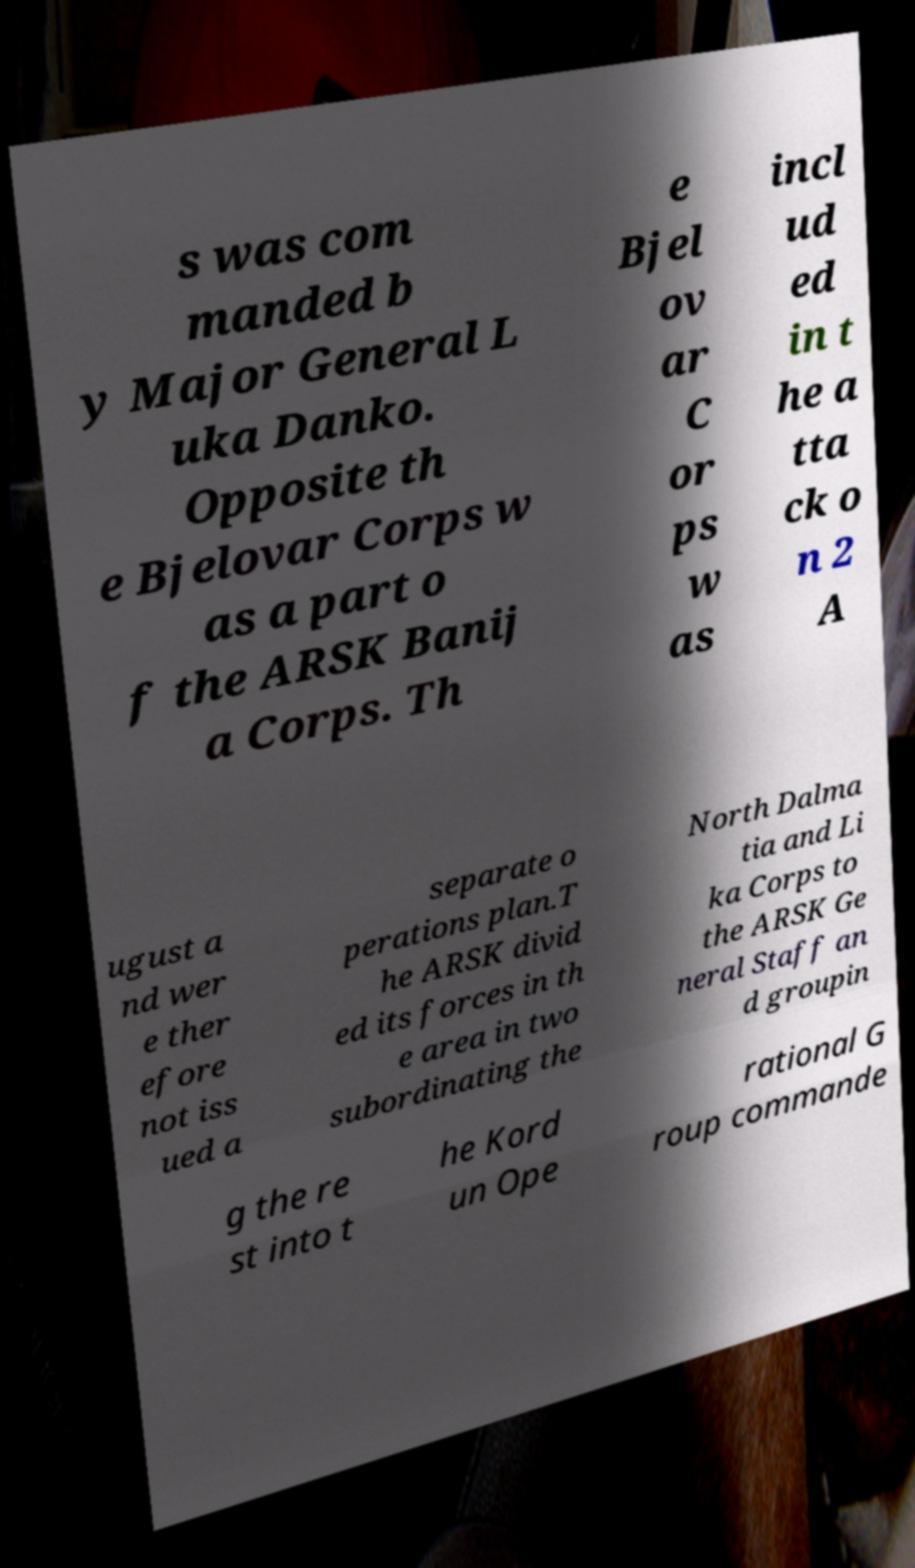Can you accurately transcribe the text from the provided image for me? s was com manded b y Major General L uka Danko. Opposite th e Bjelovar Corps w as a part o f the ARSK Banij a Corps. Th e Bjel ov ar C or ps w as incl ud ed in t he a tta ck o n 2 A ugust a nd wer e ther efore not iss ued a separate o perations plan.T he ARSK divid ed its forces in th e area in two subordinating the North Dalma tia and Li ka Corps to the ARSK Ge neral Staff an d groupin g the re st into t he Kord un Ope rational G roup commande 